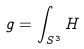Convert formula to latex. <formula><loc_0><loc_0><loc_500><loc_500>g = \int _ { S ^ { 3 } } H</formula> 